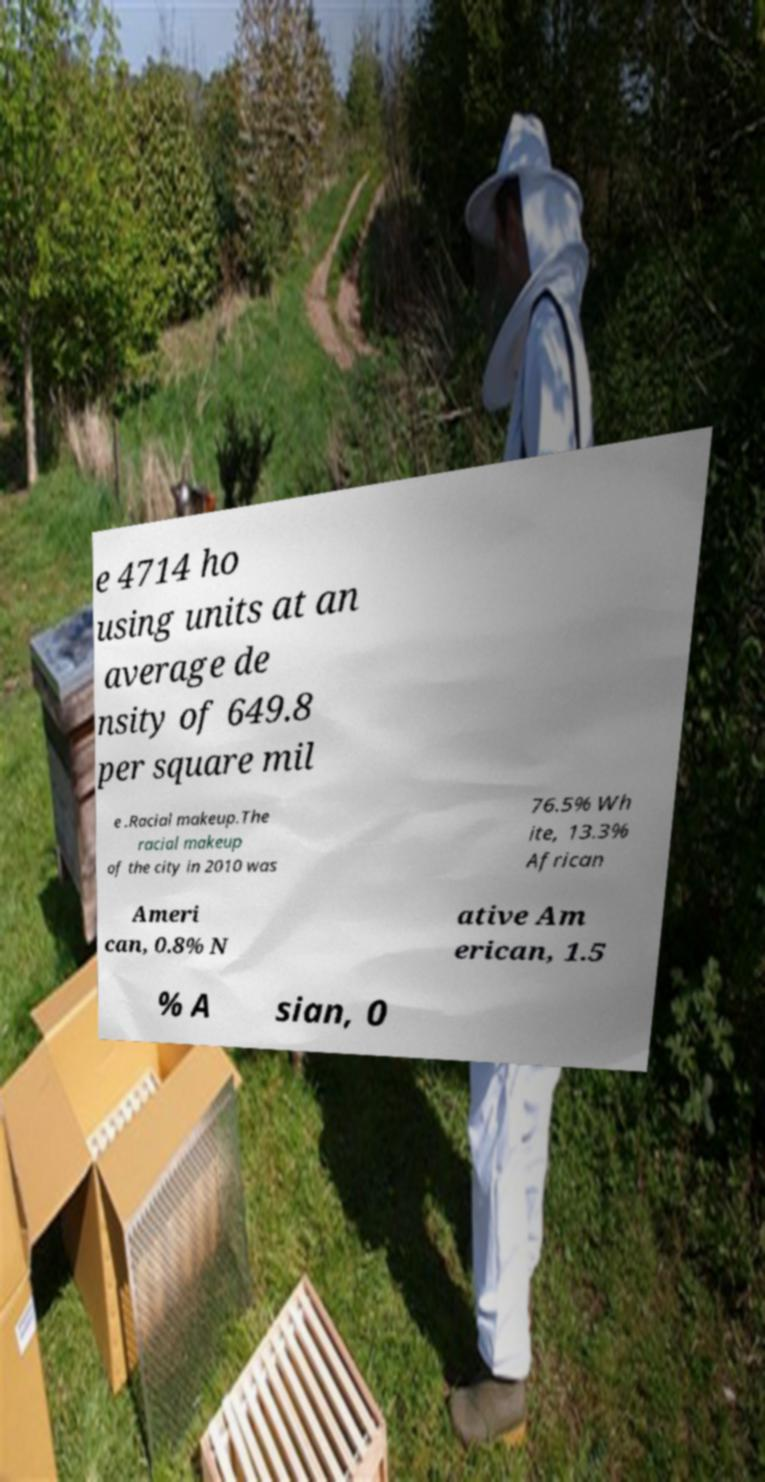Please identify and transcribe the text found in this image. e 4714 ho using units at an average de nsity of 649.8 per square mil e .Racial makeup.The racial makeup of the city in 2010 was 76.5% Wh ite, 13.3% African Ameri can, 0.8% N ative Am erican, 1.5 % A sian, 0 